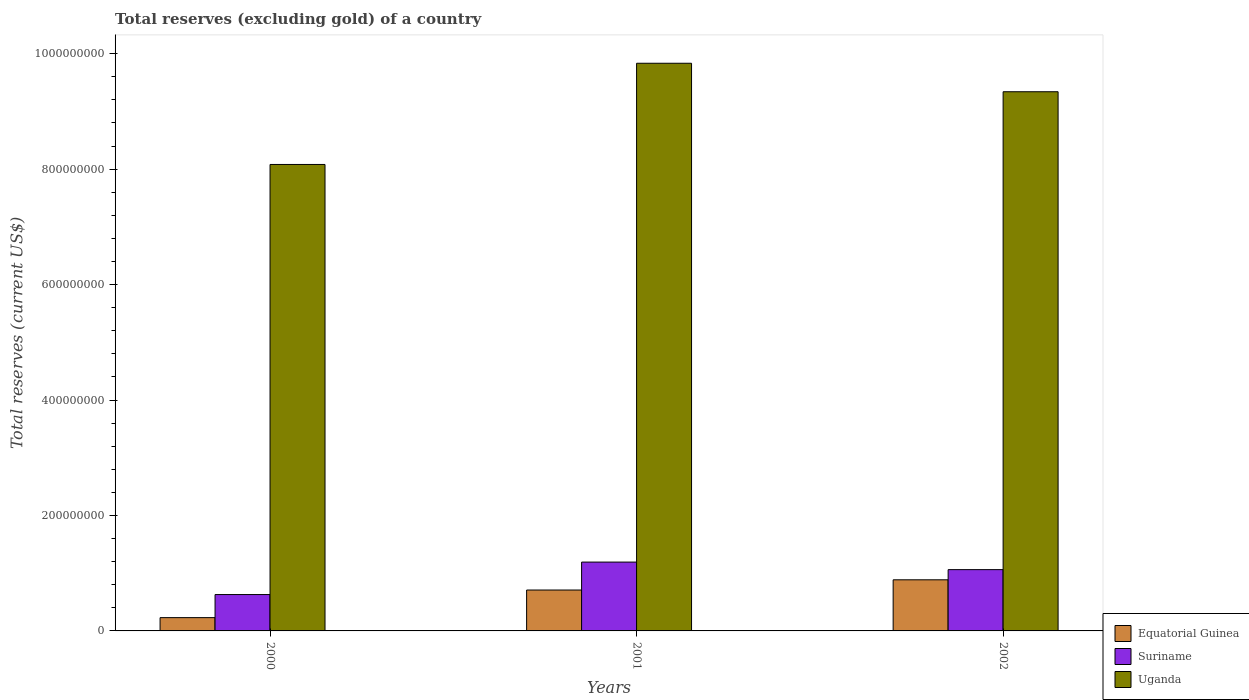How many different coloured bars are there?
Provide a succinct answer. 3. How many groups of bars are there?
Your answer should be compact. 3. Are the number of bars per tick equal to the number of legend labels?
Keep it short and to the point. Yes. How many bars are there on the 3rd tick from the left?
Make the answer very short. 3. How many bars are there on the 3rd tick from the right?
Keep it short and to the point. 3. In how many cases, is the number of bars for a given year not equal to the number of legend labels?
Provide a succinct answer. 0. What is the total reserves (excluding gold) in Uganda in 2001?
Offer a terse response. 9.83e+08. Across all years, what is the maximum total reserves (excluding gold) in Uganda?
Keep it short and to the point. 9.83e+08. Across all years, what is the minimum total reserves (excluding gold) in Uganda?
Your answer should be very brief. 8.08e+08. In which year was the total reserves (excluding gold) in Uganda maximum?
Make the answer very short. 2001. In which year was the total reserves (excluding gold) in Suriname minimum?
Your answer should be compact. 2000. What is the total total reserves (excluding gold) in Suriname in the graph?
Keep it short and to the point. 2.88e+08. What is the difference between the total reserves (excluding gold) in Equatorial Guinea in 2000 and that in 2001?
Your response must be concise. -4.78e+07. What is the difference between the total reserves (excluding gold) in Uganda in 2000 and the total reserves (excluding gold) in Suriname in 2001?
Your answer should be very brief. 6.89e+08. What is the average total reserves (excluding gold) in Equatorial Guinea per year?
Ensure brevity in your answer.  6.08e+07. In the year 2000, what is the difference between the total reserves (excluding gold) in Equatorial Guinea and total reserves (excluding gold) in Uganda?
Offer a terse response. -7.85e+08. In how many years, is the total reserves (excluding gold) in Uganda greater than 480000000 US$?
Your answer should be compact. 3. What is the ratio of the total reserves (excluding gold) in Uganda in 2001 to that in 2002?
Offer a terse response. 1.05. Is the total reserves (excluding gold) in Equatorial Guinea in 2000 less than that in 2002?
Provide a short and direct response. Yes. Is the difference between the total reserves (excluding gold) in Equatorial Guinea in 2000 and 2002 greater than the difference between the total reserves (excluding gold) in Uganda in 2000 and 2002?
Offer a very short reply. Yes. What is the difference between the highest and the second highest total reserves (excluding gold) in Equatorial Guinea?
Ensure brevity in your answer.  1.77e+07. What is the difference between the highest and the lowest total reserves (excluding gold) in Uganda?
Provide a succinct answer. 1.75e+08. What does the 3rd bar from the left in 2000 represents?
Your response must be concise. Uganda. What does the 1st bar from the right in 2001 represents?
Make the answer very short. Uganda. Is it the case that in every year, the sum of the total reserves (excluding gold) in Equatorial Guinea and total reserves (excluding gold) in Suriname is greater than the total reserves (excluding gold) in Uganda?
Provide a succinct answer. No. How many years are there in the graph?
Ensure brevity in your answer.  3. What is the difference between two consecutive major ticks on the Y-axis?
Offer a terse response. 2.00e+08. What is the title of the graph?
Give a very brief answer. Total reserves (excluding gold) of a country. Does "Iceland" appear as one of the legend labels in the graph?
Keep it short and to the point. No. What is the label or title of the Y-axis?
Provide a succinct answer. Total reserves (current US$). What is the Total reserves (current US$) in Equatorial Guinea in 2000?
Provide a short and direct response. 2.30e+07. What is the Total reserves (current US$) of Suriname in 2000?
Your answer should be very brief. 6.30e+07. What is the Total reserves (current US$) in Uganda in 2000?
Your answer should be compact. 8.08e+08. What is the Total reserves (current US$) in Equatorial Guinea in 2001?
Provide a short and direct response. 7.09e+07. What is the Total reserves (current US$) of Suriname in 2001?
Provide a succinct answer. 1.19e+08. What is the Total reserves (current US$) in Uganda in 2001?
Offer a terse response. 9.83e+08. What is the Total reserves (current US$) in Equatorial Guinea in 2002?
Ensure brevity in your answer.  8.85e+07. What is the Total reserves (current US$) of Suriname in 2002?
Provide a succinct answer. 1.06e+08. What is the Total reserves (current US$) of Uganda in 2002?
Make the answer very short. 9.34e+08. Across all years, what is the maximum Total reserves (current US$) in Equatorial Guinea?
Provide a short and direct response. 8.85e+07. Across all years, what is the maximum Total reserves (current US$) of Suriname?
Make the answer very short. 1.19e+08. Across all years, what is the maximum Total reserves (current US$) of Uganda?
Ensure brevity in your answer.  9.83e+08. Across all years, what is the minimum Total reserves (current US$) of Equatorial Guinea?
Provide a short and direct response. 2.30e+07. Across all years, what is the minimum Total reserves (current US$) of Suriname?
Provide a short and direct response. 6.30e+07. Across all years, what is the minimum Total reserves (current US$) in Uganda?
Provide a succinct answer. 8.08e+08. What is the total Total reserves (current US$) in Equatorial Guinea in the graph?
Your answer should be very brief. 1.82e+08. What is the total Total reserves (current US$) in Suriname in the graph?
Provide a short and direct response. 2.88e+08. What is the total Total reserves (current US$) in Uganda in the graph?
Your response must be concise. 2.73e+09. What is the difference between the Total reserves (current US$) in Equatorial Guinea in 2000 and that in 2001?
Your answer should be compact. -4.78e+07. What is the difference between the Total reserves (current US$) of Suriname in 2000 and that in 2001?
Make the answer very short. -5.63e+07. What is the difference between the Total reserves (current US$) in Uganda in 2000 and that in 2001?
Make the answer very short. -1.75e+08. What is the difference between the Total reserves (current US$) in Equatorial Guinea in 2000 and that in 2002?
Ensure brevity in your answer.  -6.55e+07. What is the difference between the Total reserves (current US$) in Suriname in 2000 and that in 2002?
Your answer should be compact. -4.32e+07. What is the difference between the Total reserves (current US$) of Uganda in 2000 and that in 2002?
Your response must be concise. -1.26e+08. What is the difference between the Total reserves (current US$) in Equatorial Guinea in 2001 and that in 2002?
Provide a succinct answer. -1.77e+07. What is the difference between the Total reserves (current US$) in Suriname in 2001 and that in 2002?
Your answer should be very brief. 1.31e+07. What is the difference between the Total reserves (current US$) in Uganda in 2001 and that in 2002?
Your response must be concise. 4.93e+07. What is the difference between the Total reserves (current US$) of Equatorial Guinea in 2000 and the Total reserves (current US$) of Suriname in 2001?
Provide a short and direct response. -9.62e+07. What is the difference between the Total reserves (current US$) of Equatorial Guinea in 2000 and the Total reserves (current US$) of Uganda in 2001?
Give a very brief answer. -9.60e+08. What is the difference between the Total reserves (current US$) of Suriname in 2000 and the Total reserves (current US$) of Uganda in 2001?
Your answer should be very brief. -9.20e+08. What is the difference between the Total reserves (current US$) in Equatorial Guinea in 2000 and the Total reserves (current US$) in Suriname in 2002?
Your response must be concise. -8.32e+07. What is the difference between the Total reserves (current US$) of Equatorial Guinea in 2000 and the Total reserves (current US$) of Uganda in 2002?
Offer a terse response. -9.11e+08. What is the difference between the Total reserves (current US$) of Suriname in 2000 and the Total reserves (current US$) of Uganda in 2002?
Give a very brief answer. -8.71e+08. What is the difference between the Total reserves (current US$) of Equatorial Guinea in 2001 and the Total reserves (current US$) of Suriname in 2002?
Your response must be concise. -3.53e+07. What is the difference between the Total reserves (current US$) in Equatorial Guinea in 2001 and the Total reserves (current US$) in Uganda in 2002?
Make the answer very short. -8.63e+08. What is the difference between the Total reserves (current US$) in Suriname in 2001 and the Total reserves (current US$) in Uganda in 2002?
Offer a terse response. -8.15e+08. What is the average Total reserves (current US$) of Equatorial Guinea per year?
Offer a terse response. 6.08e+07. What is the average Total reserves (current US$) in Suriname per year?
Provide a succinct answer. 9.61e+07. What is the average Total reserves (current US$) of Uganda per year?
Make the answer very short. 9.08e+08. In the year 2000, what is the difference between the Total reserves (current US$) in Equatorial Guinea and Total reserves (current US$) in Suriname?
Ensure brevity in your answer.  -4.00e+07. In the year 2000, what is the difference between the Total reserves (current US$) of Equatorial Guinea and Total reserves (current US$) of Uganda?
Make the answer very short. -7.85e+08. In the year 2000, what is the difference between the Total reserves (current US$) of Suriname and Total reserves (current US$) of Uganda?
Your response must be concise. -7.45e+08. In the year 2001, what is the difference between the Total reserves (current US$) of Equatorial Guinea and Total reserves (current US$) of Suriname?
Make the answer very short. -4.84e+07. In the year 2001, what is the difference between the Total reserves (current US$) in Equatorial Guinea and Total reserves (current US$) in Uganda?
Keep it short and to the point. -9.13e+08. In the year 2001, what is the difference between the Total reserves (current US$) of Suriname and Total reserves (current US$) of Uganda?
Your answer should be compact. -8.64e+08. In the year 2002, what is the difference between the Total reserves (current US$) of Equatorial Guinea and Total reserves (current US$) of Suriname?
Provide a short and direct response. -1.76e+07. In the year 2002, what is the difference between the Total reserves (current US$) of Equatorial Guinea and Total reserves (current US$) of Uganda?
Your answer should be very brief. -8.45e+08. In the year 2002, what is the difference between the Total reserves (current US$) in Suriname and Total reserves (current US$) in Uganda?
Ensure brevity in your answer.  -8.28e+08. What is the ratio of the Total reserves (current US$) of Equatorial Guinea in 2000 to that in 2001?
Offer a very short reply. 0.32. What is the ratio of the Total reserves (current US$) of Suriname in 2000 to that in 2001?
Your answer should be compact. 0.53. What is the ratio of the Total reserves (current US$) in Uganda in 2000 to that in 2001?
Offer a very short reply. 0.82. What is the ratio of the Total reserves (current US$) in Equatorial Guinea in 2000 to that in 2002?
Offer a very short reply. 0.26. What is the ratio of the Total reserves (current US$) of Suriname in 2000 to that in 2002?
Your response must be concise. 0.59. What is the ratio of the Total reserves (current US$) in Uganda in 2000 to that in 2002?
Your answer should be very brief. 0.87. What is the ratio of the Total reserves (current US$) in Equatorial Guinea in 2001 to that in 2002?
Provide a short and direct response. 0.8. What is the ratio of the Total reserves (current US$) of Suriname in 2001 to that in 2002?
Offer a terse response. 1.12. What is the ratio of the Total reserves (current US$) in Uganda in 2001 to that in 2002?
Your answer should be very brief. 1.05. What is the difference between the highest and the second highest Total reserves (current US$) of Equatorial Guinea?
Keep it short and to the point. 1.77e+07. What is the difference between the highest and the second highest Total reserves (current US$) of Suriname?
Offer a terse response. 1.31e+07. What is the difference between the highest and the second highest Total reserves (current US$) in Uganda?
Give a very brief answer. 4.93e+07. What is the difference between the highest and the lowest Total reserves (current US$) of Equatorial Guinea?
Make the answer very short. 6.55e+07. What is the difference between the highest and the lowest Total reserves (current US$) in Suriname?
Keep it short and to the point. 5.63e+07. What is the difference between the highest and the lowest Total reserves (current US$) in Uganda?
Offer a terse response. 1.75e+08. 